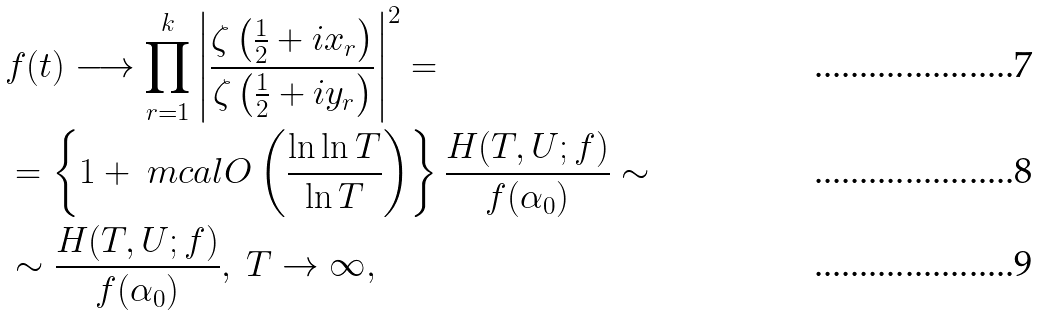<formula> <loc_0><loc_0><loc_500><loc_500>& f ( t ) \longrightarrow \prod _ { r = 1 } ^ { k } \left | \frac { \zeta \left ( \frac { 1 } { 2 } + i x _ { r } \right ) } { \zeta \left ( \frac { 1 } { 2 } + i y _ { r } \right ) } \right | ^ { 2 } = \\ & = \left \{ 1 + \ m c a l { O } \left ( \frac { \ln \ln T } { \ln T } \right ) \right \} \frac { H ( T , U ; f ) } { f ( \alpha _ { 0 } ) } \sim \\ & \sim \frac { H ( T , U ; f ) } { f ( \alpha _ { 0 } ) } , \ T \to \infty ,</formula> 